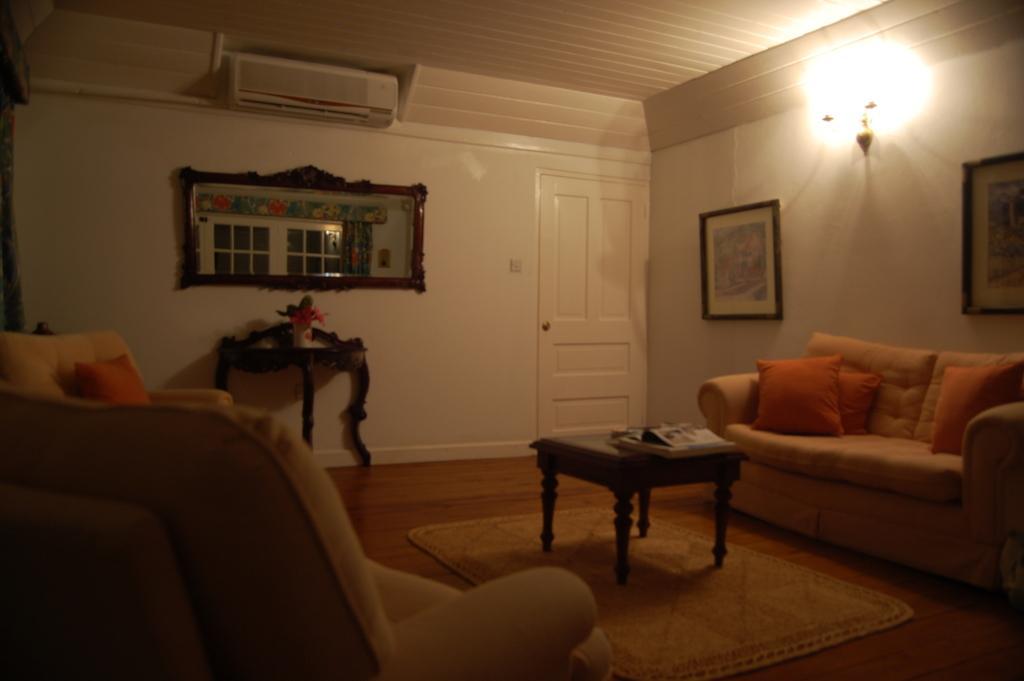Could you give a brief overview of what you see in this image? In this image i can see 2 couches, few pillows on them. In the background i can see a wall, a door , a photo frame, air conditioner, light and a mirror. 